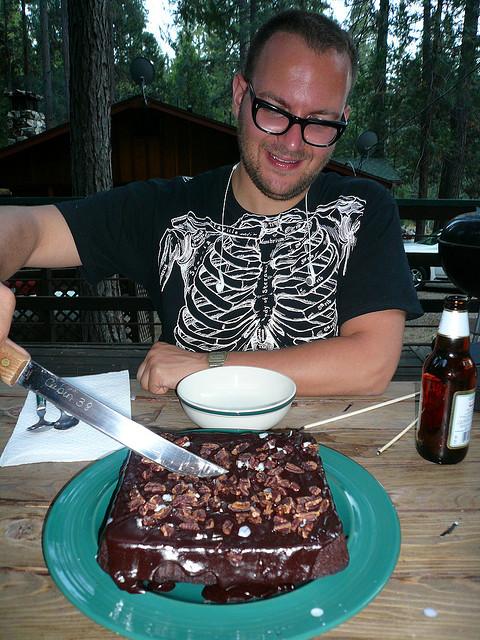What are the brown things on the plate?
Keep it brief. Cake. What is printed on his t shirt?
Keep it brief. Skeleton. What is the guy doing?
Write a very short answer. Cutting cake. 